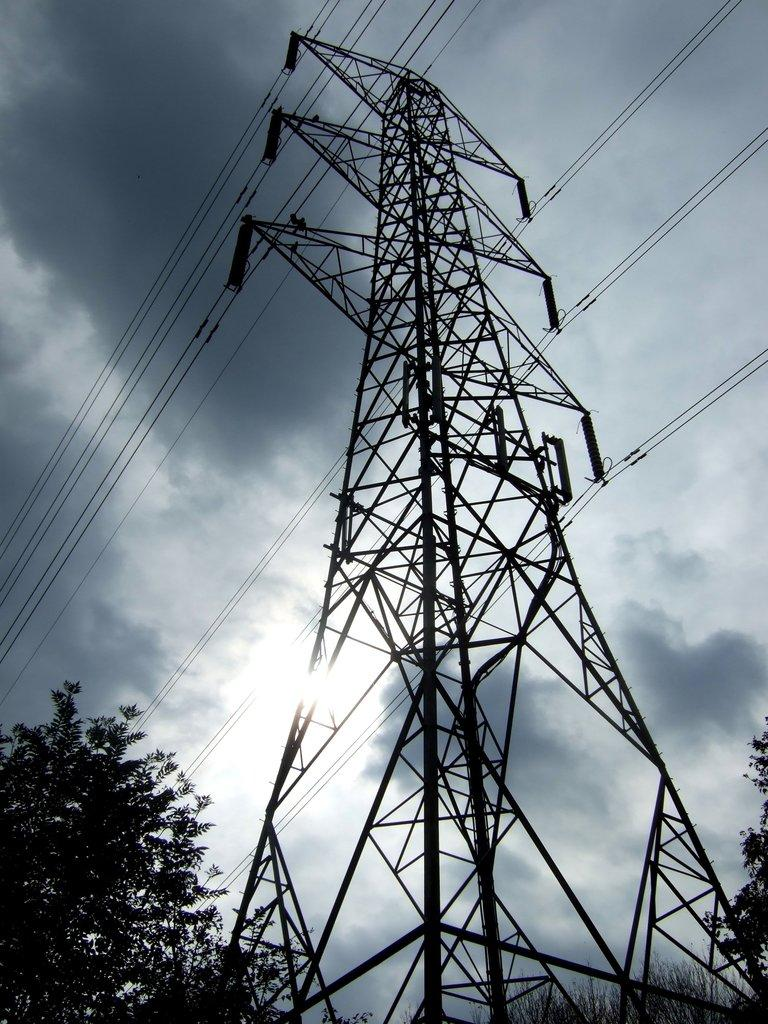What is the main structure in the center of the image? There is an electric tower in the center of the image. How are the cables connected to the electric tower? The electric tower is connected with cables. What type of vegetation can be seen on both sides of the image? There are trees on the right side and the left side of the image. What is visible in the background of the image? The sky is visible in the background of the image. What type of toothpaste is being used to clean the electric tower in the image? There is no toothpaste present in the image, and the electric tower is not being cleaned. Can you see any cherries on the electric tower in the image? There are no cherries present on the electric tower in the image. 